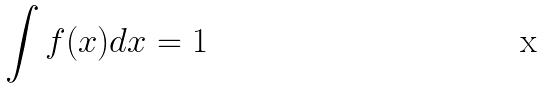<formula> <loc_0><loc_0><loc_500><loc_500>\int f ( x ) d x = 1</formula> 